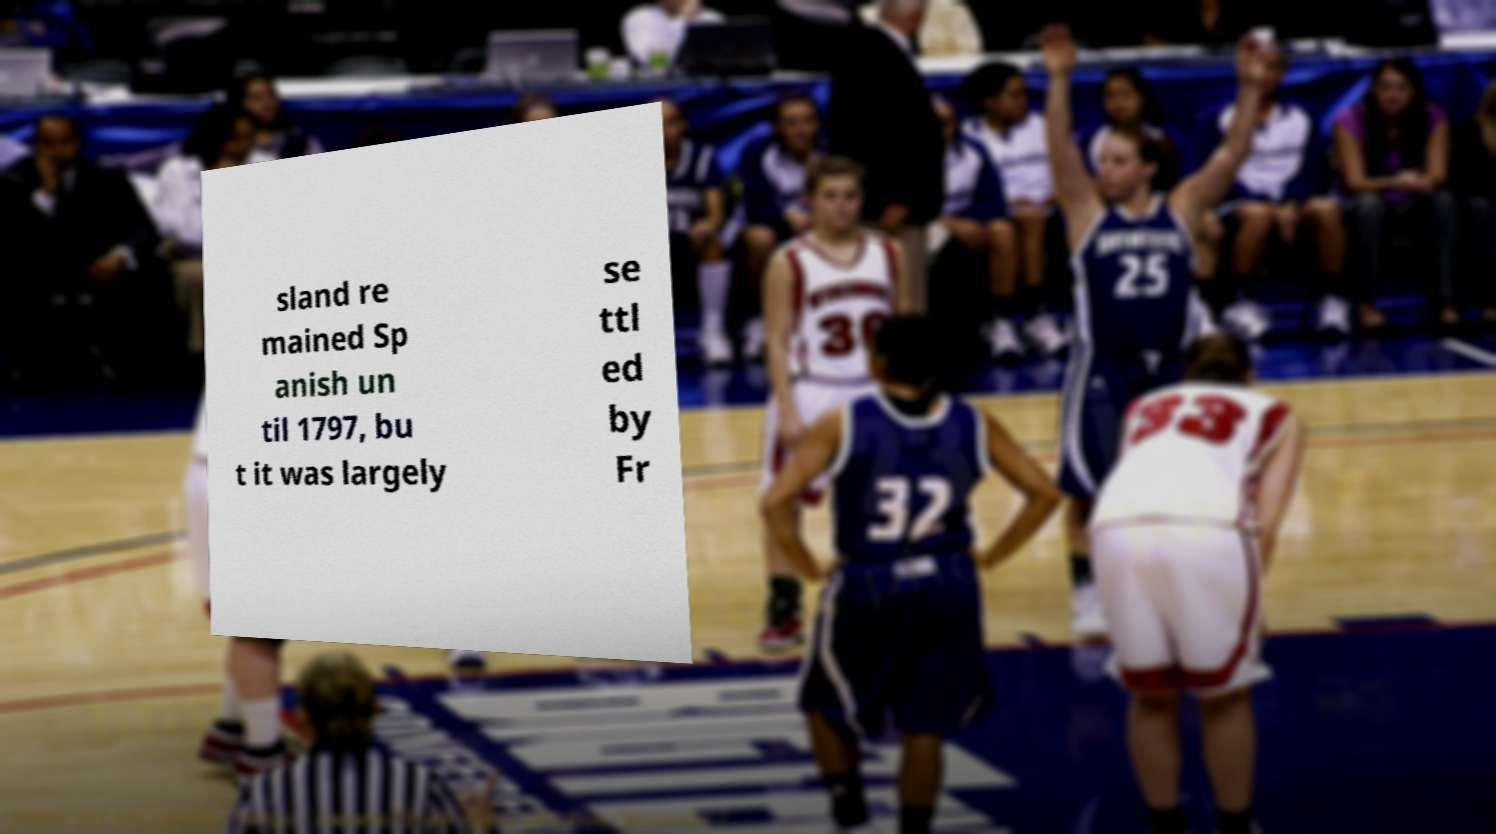Can you read and provide the text displayed in the image?This photo seems to have some interesting text. Can you extract and type it out for me? sland re mained Sp anish un til 1797, bu t it was largely se ttl ed by Fr 